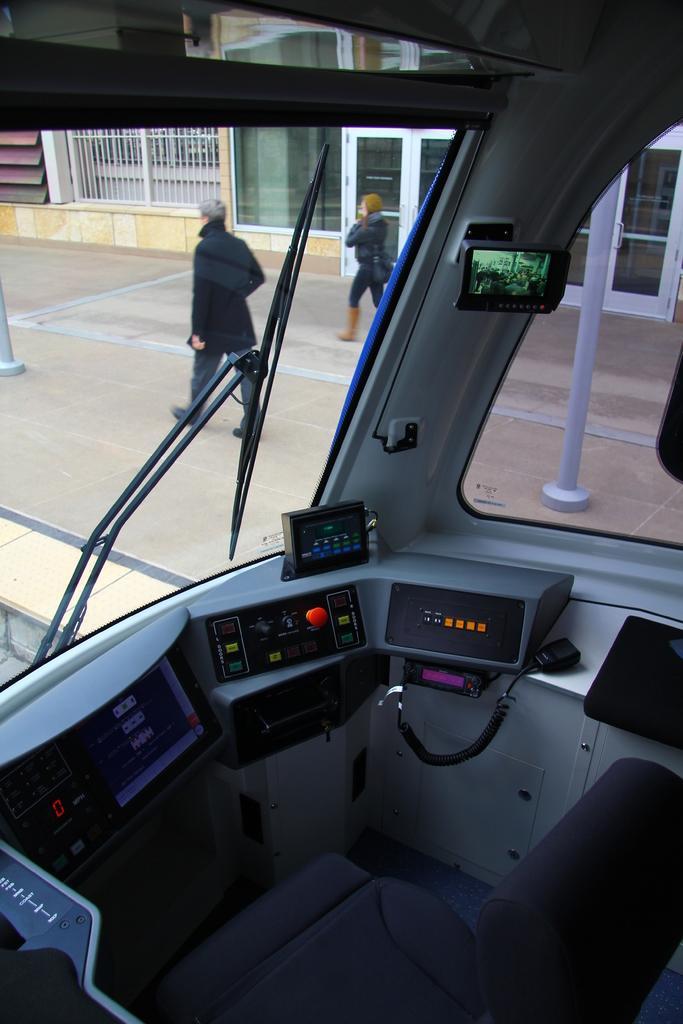Describe this image in one or two sentences. In this picture I can see the inside view of a vehicle. There are two persons standing, and in the background there is a building. 